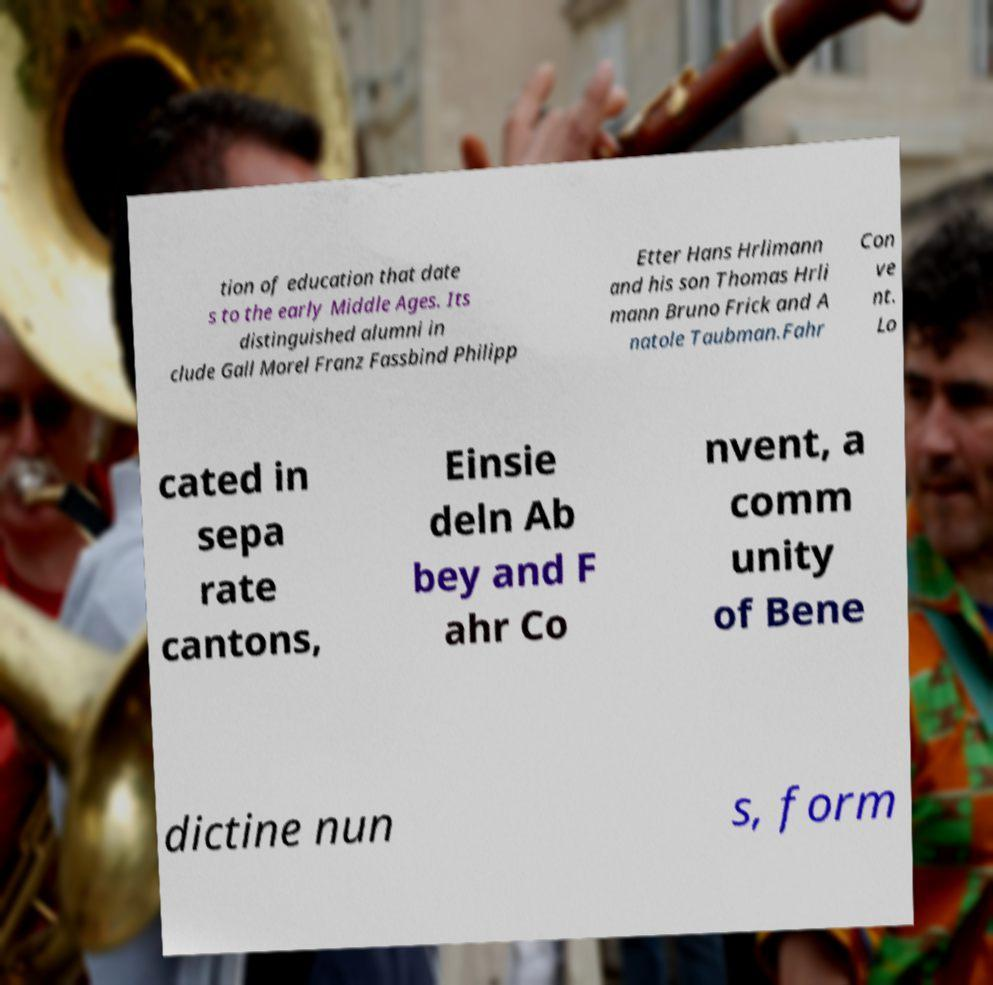Can you read and provide the text displayed in the image?This photo seems to have some interesting text. Can you extract and type it out for me? tion of education that date s to the early Middle Ages. Its distinguished alumni in clude Gall Morel Franz Fassbind Philipp Etter Hans Hrlimann and his son Thomas Hrli mann Bruno Frick and A natole Taubman.Fahr Con ve nt. Lo cated in sepa rate cantons, Einsie deln Ab bey and F ahr Co nvent, a comm unity of Bene dictine nun s, form 